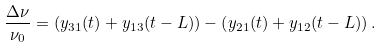<formula> <loc_0><loc_0><loc_500><loc_500>\frac { \Delta \nu } { \nu _ { 0 } } = \left ( y _ { 3 1 } ( t ) + y _ { 1 3 } ( t - L ) \right ) - \left ( y _ { 2 1 } ( t ) + y _ { 1 2 } ( t - L ) \right ) .</formula> 